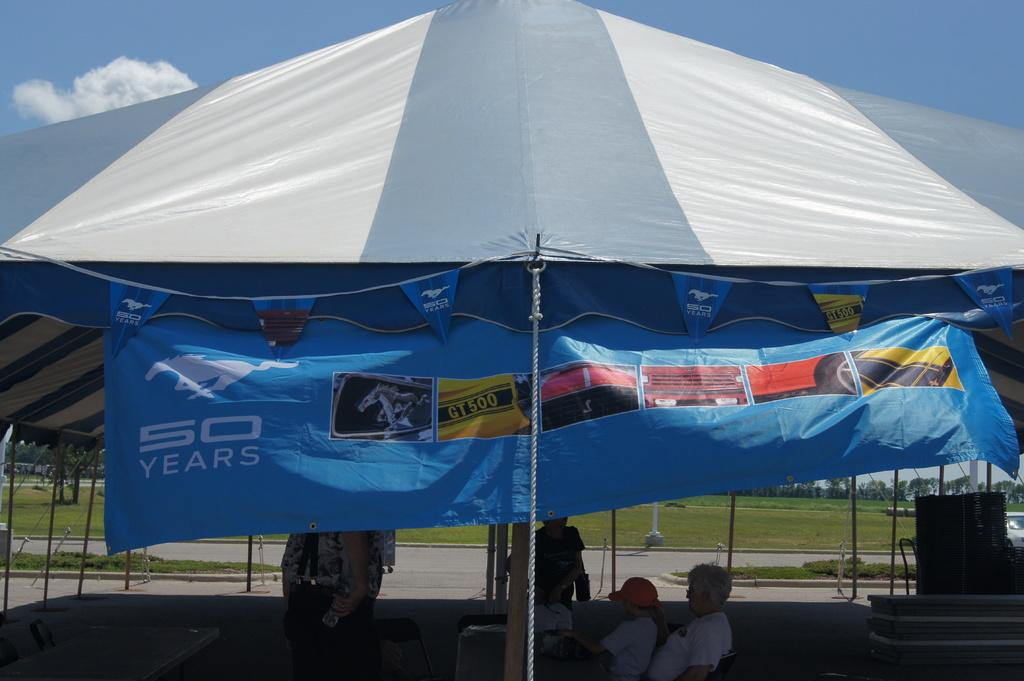What structure can be seen in the image? There is a tent in the image. What are the people in the image doing? The people are sitting under the tent. What is visible in the sky in the image? Clouds are present in the sky. What type of terrain is visible in the background of the image? There is a grassland in the background of the image. What type of collar is visible on the grass in the image? There is no collar present in the image; it features a tent, people sitting under the tent, clouds in the sky, and a grassland in the background. 